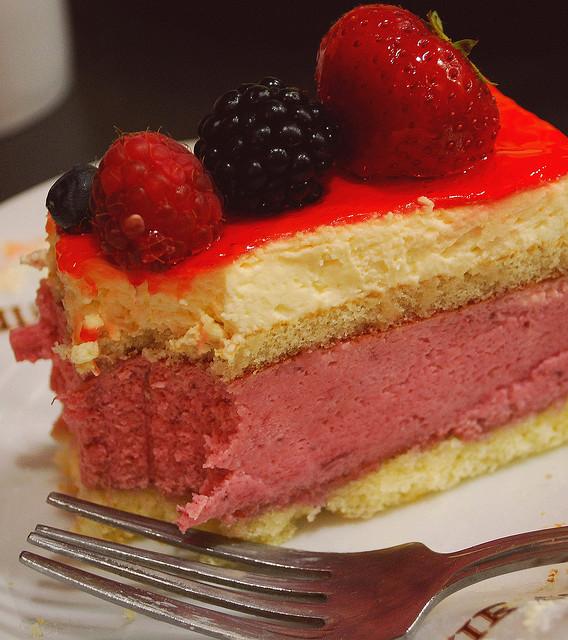What utensil is next to the cake?
Write a very short answer. Fork. Is this dessert a fruit cake?
Keep it brief. Yes. What kind of food is this?
Keep it brief. Cake. How many cherries are there?
Write a very short answer. 0. On top of the cake are four items of what classification?
Keep it brief. Fruit. Is there ketchup on the cake?
Write a very short answer. No. Is this cake frosted with fondant?
Keep it brief. No. How many layers is the cake?
Quick response, please. 3. 